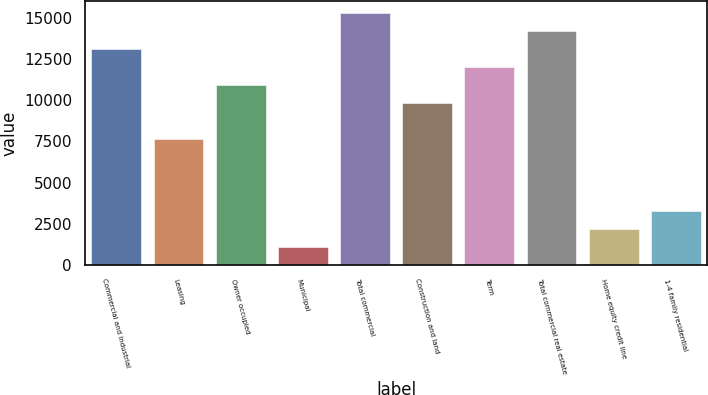Convert chart to OTSL. <chart><loc_0><loc_0><loc_500><loc_500><bar_chart><fcel>Commercial and industrial<fcel>Leasing<fcel>Owner occupied<fcel>Municipal<fcel>Total commercial<fcel>Construction and land<fcel>Term<fcel>Total commercial real estate<fcel>Home equity credit line<fcel>1-4 family residential<nl><fcel>13076.6<fcel>7632.6<fcel>10899<fcel>1099.8<fcel>15254.2<fcel>9810.2<fcel>11987.8<fcel>14165.4<fcel>2188.6<fcel>3277.4<nl></chart> 